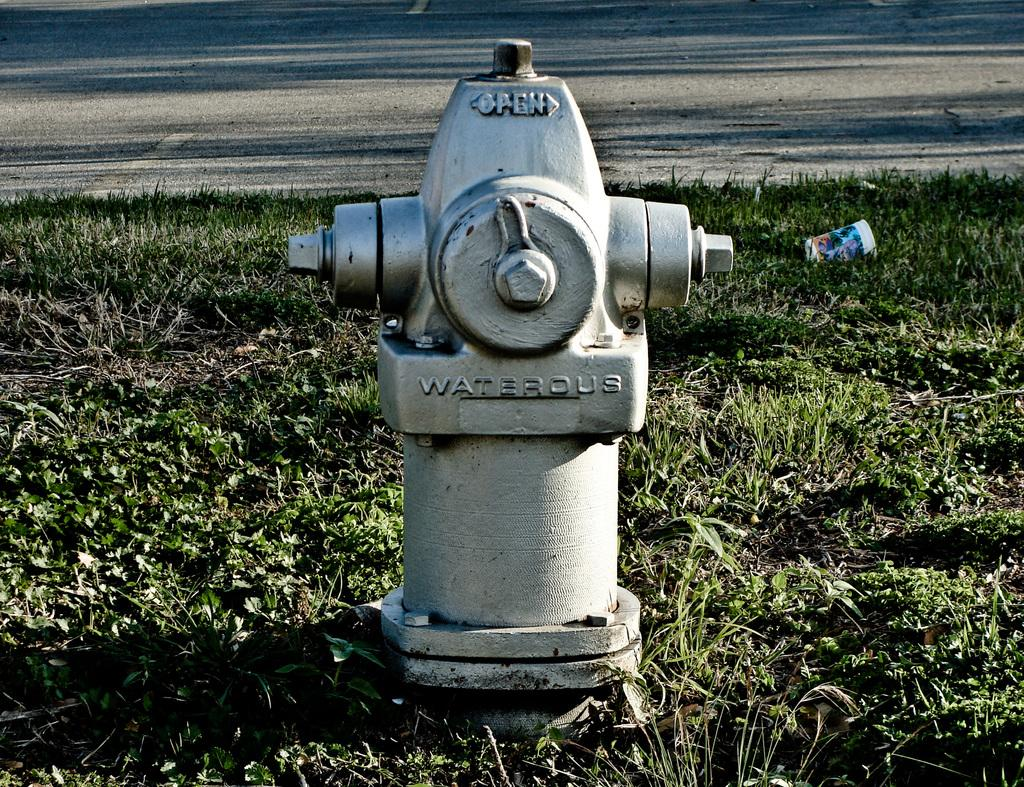What object can be seen in the image that is used for firefighting? There is a fire hydrant in the image. What type of vegetation is visible in the image? There is grass visible in the image. How many tickets did the son receive for talking during class? There is no information about tickets, talking, or a son in the image, so this question cannot be answered. 